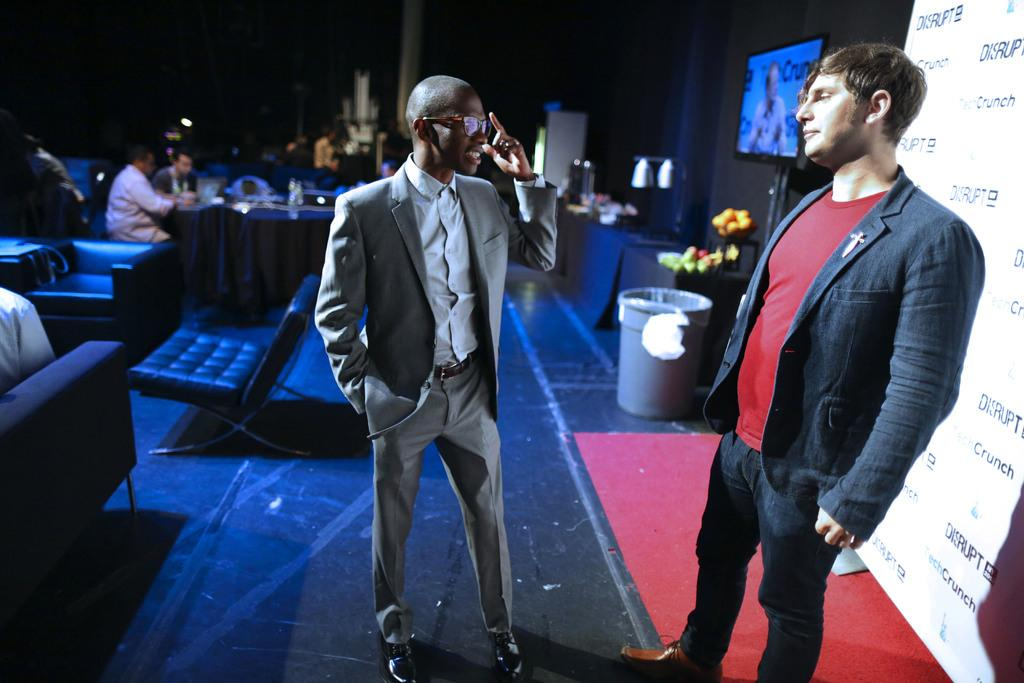How many people are in the image? There are people in the image, but the exact number is not specified. What is hanging in the image? There is a banner in the image. What is used for displaying information or visuals in the image? There is a screen in the image. What is used for holding or carrying items in the image? There is a bucket in the image. What type of furniture is present in the image? There are sofas in the image. What is used for placing items or serving food in the image? There is a table in the image. How would you describe the lighting in the image? The image is a little dark. What direction is the north pole pointing in the image? There is no reference to a north pole or any directional indicators in the image. 